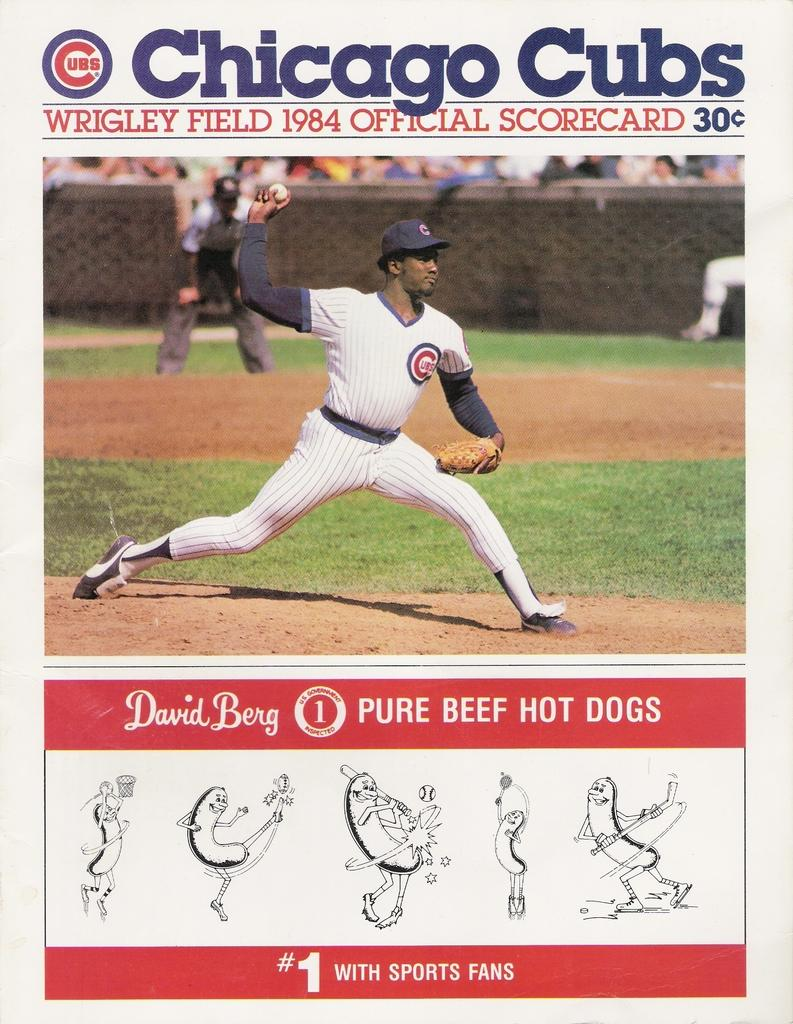<image>
Render a clear and concise summary of the photo. a paper that is titled 'chicago cubs' on it 